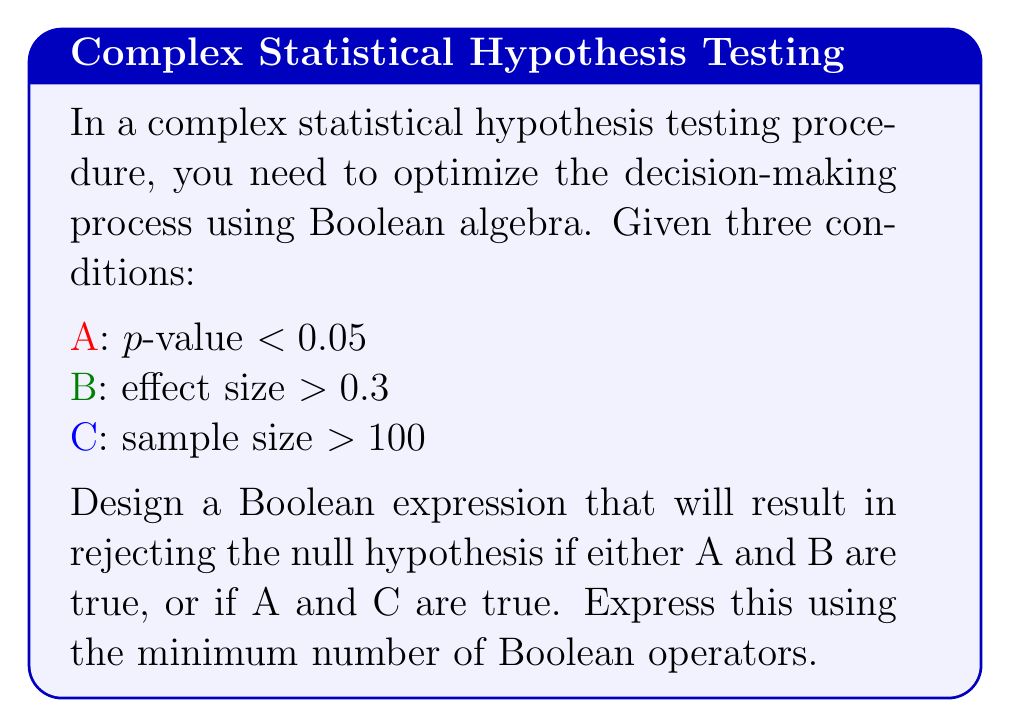Solve this math problem. To solve this problem, we'll use Boolean algebra to construct and simplify the expression:

1. First, let's express the conditions for rejecting the null hypothesis:
   (A AND B) OR (A AND C)

2. In Boolean algebra, this can be written as:
   $$(A \land B) \lor (A \land C)$$

3. We can factor out A using the distributive property:
   $$A \land (B \lor C)$$

4. This expression uses the minimum number of Boolean operators (two) to represent the given conditions.

5. To verify:
   - If A and B are true, C can be either true or false, and the expression will evaluate to true.
   - If A and C are true, B can be either true or false, and the expression will evaluate to true.
   - If A is false, the entire expression will be false regardless of B and C.

This optimized Boolean expression allows for efficient decision-making in the hypothesis testing procedure, as it requires evaluating only two Boolean operations in the worst case.
Answer: $$A \land (B \lor C)$$ 